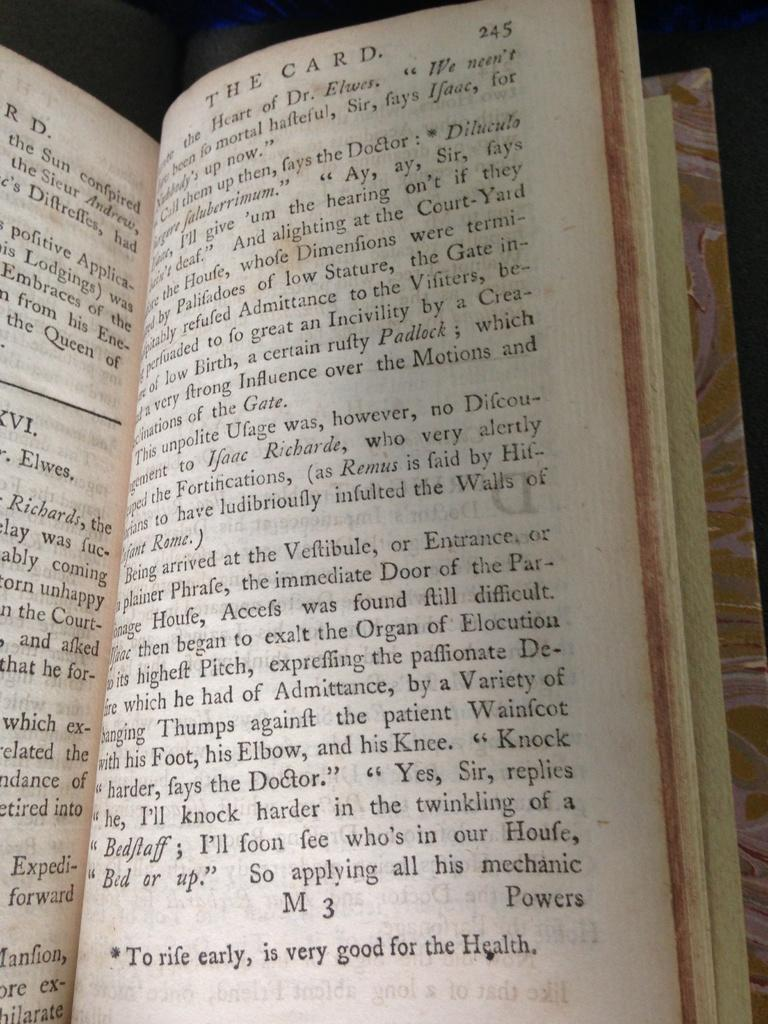<image>
Create a compact narrative representing the image presented. The book titled "The Card" opened to page 245. 